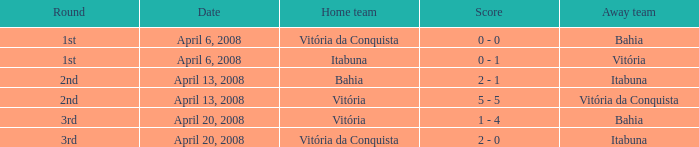Who played as the home team when Vitória was the away team? Itabuna. 